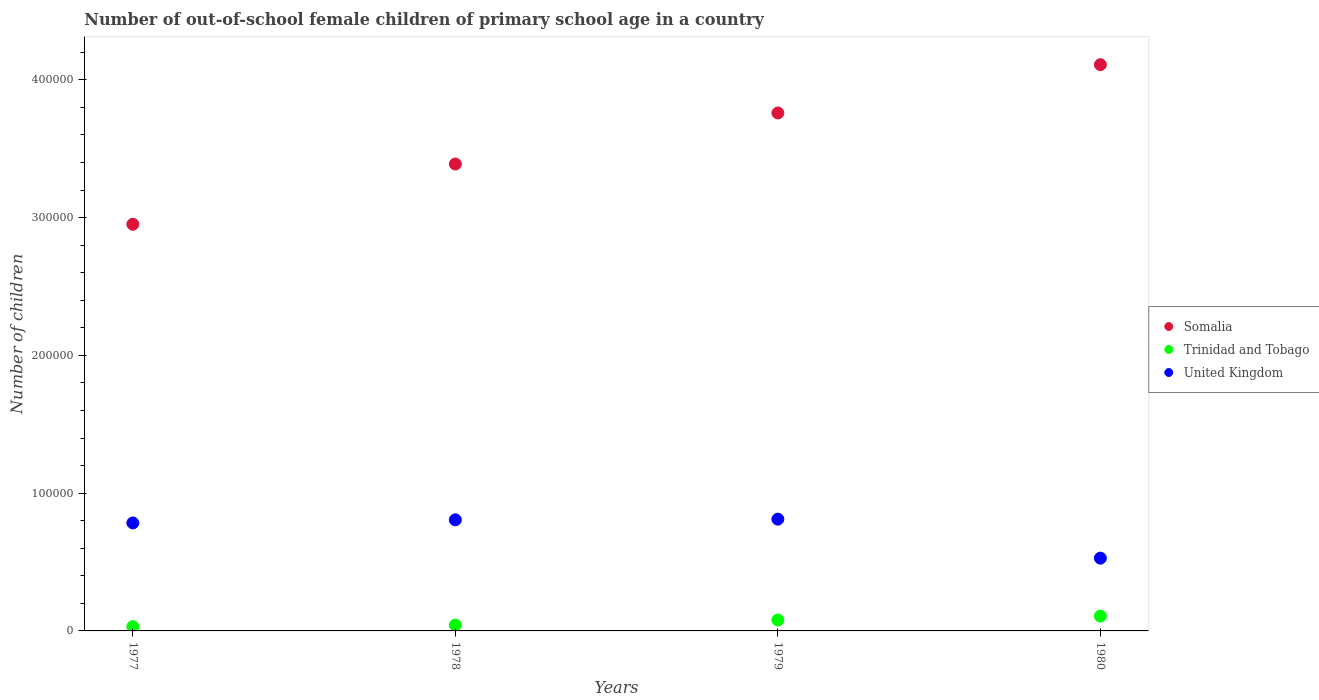How many different coloured dotlines are there?
Your response must be concise. 3. What is the number of out-of-school female children in United Kingdom in 1980?
Ensure brevity in your answer.  5.28e+04. Across all years, what is the maximum number of out-of-school female children in Trinidad and Tobago?
Provide a short and direct response. 1.08e+04. Across all years, what is the minimum number of out-of-school female children in Somalia?
Your answer should be very brief. 2.95e+05. In which year was the number of out-of-school female children in Trinidad and Tobago maximum?
Provide a short and direct response. 1980. What is the total number of out-of-school female children in United Kingdom in the graph?
Ensure brevity in your answer.  2.93e+05. What is the difference between the number of out-of-school female children in Somalia in 1977 and that in 1979?
Give a very brief answer. -8.08e+04. What is the difference between the number of out-of-school female children in Somalia in 1979 and the number of out-of-school female children in United Kingdom in 1980?
Ensure brevity in your answer.  3.23e+05. What is the average number of out-of-school female children in Trinidad and Tobago per year?
Keep it short and to the point. 6522.25. In the year 1978, what is the difference between the number of out-of-school female children in Somalia and number of out-of-school female children in Trinidad and Tobago?
Your response must be concise. 3.35e+05. In how many years, is the number of out-of-school female children in United Kingdom greater than 60000?
Make the answer very short. 3. What is the ratio of the number of out-of-school female children in Somalia in 1978 to that in 1980?
Your response must be concise. 0.82. What is the difference between the highest and the second highest number of out-of-school female children in United Kingdom?
Offer a terse response. 479. What is the difference between the highest and the lowest number of out-of-school female children in Trinidad and Tobago?
Your answer should be compact. 7644. Is it the case that in every year, the sum of the number of out-of-school female children in Somalia and number of out-of-school female children in Trinidad and Tobago  is greater than the number of out-of-school female children in United Kingdom?
Make the answer very short. Yes. Does the number of out-of-school female children in United Kingdom monotonically increase over the years?
Provide a short and direct response. No. Is the number of out-of-school female children in United Kingdom strictly less than the number of out-of-school female children in Somalia over the years?
Ensure brevity in your answer.  Yes. How many dotlines are there?
Your answer should be very brief. 3. Does the graph contain grids?
Your response must be concise. No. What is the title of the graph?
Give a very brief answer. Number of out-of-school female children of primary school age in a country. What is the label or title of the Y-axis?
Give a very brief answer. Number of children. What is the Number of children of Somalia in 1977?
Provide a succinct answer. 2.95e+05. What is the Number of children in Trinidad and Tobago in 1977?
Keep it short and to the point. 3116. What is the Number of children in United Kingdom in 1977?
Provide a short and direct response. 7.84e+04. What is the Number of children in Somalia in 1978?
Your response must be concise. 3.39e+05. What is the Number of children of Trinidad and Tobago in 1978?
Offer a very short reply. 4266. What is the Number of children in United Kingdom in 1978?
Provide a short and direct response. 8.06e+04. What is the Number of children in Somalia in 1979?
Ensure brevity in your answer.  3.76e+05. What is the Number of children in Trinidad and Tobago in 1979?
Ensure brevity in your answer.  7947. What is the Number of children of United Kingdom in 1979?
Offer a terse response. 8.11e+04. What is the Number of children of Somalia in 1980?
Make the answer very short. 4.11e+05. What is the Number of children in Trinidad and Tobago in 1980?
Your answer should be compact. 1.08e+04. What is the Number of children in United Kingdom in 1980?
Your answer should be compact. 5.28e+04. Across all years, what is the maximum Number of children in Somalia?
Provide a short and direct response. 4.11e+05. Across all years, what is the maximum Number of children of Trinidad and Tobago?
Offer a very short reply. 1.08e+04. Across all years, what is the maximum Number of children of United Kingdom?
Offer a very short reply. 8.11e+04. Across all years, what is the minimum Number of children in Somalia?
Provide a succinct answer. 2.95e+05. Across all years, what is the minimum Number of children in Trinidad and Tobago?
Keep it short and to the point. 3116. Across all years, what is the minimum Number of children in United Kingdom?
Offer a terse response. 5.28e+04. What is the total Number of children in Somalia in the graph?
Your response must be concise. 1.42e+06. What is the total Number of children in Trinidad and Tobago in the graph?
Provide a short and direct response. 2.61e+04. What is the total Number of children of United Kingdom in the graph?
Ensure brevity in your answer.  2.93e+05. What is the difference between the Number of children of Somalia in 1977 and that in 1978?
Your answer should be very brief. -4.37e+04. What is the difference between the Number of children of Trinidad and Tobago in 1977 and that in 1978?
Your response must be concise. -1150. What is the difference between the Number of children of United Kingdom in 1977 and that in 1978?
Your answer should be very brief. -2261. What is the difference between the Number of children in Somalia in 1977 and that in 1979?
Offer a very short reply. -8.08e+04. What is the difference between the Number of children of Trinidad and Tobago in 1977 and that in 1979?
Offer a very short reply. -4831. What is the difference between the Number of children of United Kingdom in 1977 and that in 1979?
Your response must be concise. -2740. What is the difference between the Number of children of Somalia in 1977 and that in 1980?
Your response must be concise. -1.16e+05. What is the difference between the Number of children in Trinidad and Tobago in 1977 and that in 1980?
Offer a terse response. -7644. What is the difference between the Number of children in United Kingdom in 1977 and that in 1980?
Give a very brief answer. 2.56e+04. What is the difference between the Number of children of Somalia in 1978 and that in 1979?
Ensure brevity in your answer.  -3.71e+04. What is the difference between the Number of children in Trinidad and Tobago in 1978 and that in 1979?
Keep it short and to the point. -3681. What is the difference between the Number of children of United Kingdom in 1978 and that in 1979?
Your answer should be very brief. -479. What is the difference between the Number of children of Somalia in 1978 and that in 1980?
Keep it short and to the point. -7.21e+04. What is the difference between the Number of children in Trinidad and Tobago in 1978 and that in 1980?
Give a very brief answer. -6494. What is the difference between the Number of children in United Kingdom in 1978 and that in 1980?
Your answer should be compact. 2.78e+04. What is the difference between the Number of children in Somalia in 1979 and that in 1980?
Your answer should be compact. -3.51e+04. What is the difference between the Number of children in Trinidad and Tobago in 1979 and that in 1980?
Provide a short and direct response. -2813. What is the difference between the Number of children in United Kingdom in 1979 and that in 1980?
Offer a very short reply. 2.83e+04. What is the difference between the Number of children in Somalia in 1977 and the Number of children in Trinidad and Tobago in 1978?
Your answer should be compact. 2.91e+05. What is the difference between the Number of children in Somalia in 1977 and the Number of children in United Kingdom in 1978?
Keep it short and to the point. 2.15e+05. What is the difference between the Number of children in Trinidad and Tobago in 1977 and the Number of children in United Kingdom in 1978?
Make the answer very short. -7.75e+04. What is the difference between the Number of children in Somalia in 1977 and the Number of children in Trinidad and Tobago in 1979?
Provide a succinct answer. 2.87e+05. What is the difference between the Number of children in Somalia in 1977 and the Number of children in United Kingdom in 1979?
Ensure brevity in your answer.  2.14e+05. What is the difference between the Number of children of Trinidad and Tobago in 1977 and the Number of children of United Kingdom in 1979?
Ensure brevity in your answer.  -7.80e+04. What is the difference between the Number of children of Somalia in 1977 and the Number of children of Trinidad and Tobago in 1980?
Provide a short and direct response. 2.84e+05. What is the difference between the Number of children of Somalia in 1977 and the Number of children of United Kingdom in 1980?
Offer a very short reply. 2.42e+05. What is the difference between the Number of children of Trinidad and Tobago in 1977 and the Number of children of United Kingdom in 1980?
Provide a succinct answer. -4.97e+04. What is the difference between the Number of children in Somalia in 1978 and the Number of children in Trinidad and Tobago in 1979?
Offer a terse response. 3.31e+05. What is the difference between the Number of children in Somalia in 1978 and the Number of children in United Kingdom in 1979?
Make the answer very short. 2.58e+05. What is the difference between the Number of children in Trinidad and Tobago in 1978 and the Number of children in United Kingdom in 1979?
Make the answer very short. -7.69e+04. What is the difference between the Number of children of Somalia in 1978 and the Number of children of Trinidad and Tobago in 1980?
Offer a very short reply. 3.28e+05. What is the difference between the Number of children of Somalia in 1978 and the Number of children of United Kingdom in 1980?
Your response must be concise. 2.86e+05. What is the difference between the Number of children of Trinidad and Tobago in 1978 and the Number of children of United Kingdom in 1980?
Give a very brief answer. -4.85e+04. What is the difference between the Number of children in Somalia in 1979 and the Number of children in Trinidad and Tobago in 1980?
Give a very brief answer. 3.65e+05. What is the difference between the Number of children of Somalia in 1979 and the Number of children of United Kingdom in 1980?
Your response must be concise. 3.23e+05. What is the difference between the Number of children of Trinidad and Tobago in 1979 and the Number of children of United Kingdom in 1980?
Provide a short and direct response. -4.49e+04. What is the average Number of children in Somalia per year?
Make the answer very short. 3.55e+05. What is the average Number of children in Trinidad and Tobago per year?
Offer a very short reply. 6522.25. What is the average Number of children in United Kingdom per year?
Provide a succinct answer. 7.32e+04. In the year 1977, what is the difference between the Number of children in Somalia and Number of children in Trinidad and Tobago?
Your response must be concise. 2.92e+05. In the year 1977, what is the difference between the Number of children of Somalia and Number of children of United Kingdom?
Your answer should be compact. 2.17e+05. In the year 1977, what is the difference between the Number of children of Trinidad and Tobago and Number of children of United Kingdom?
Make the answer very short. -7.53e+04. In the year 1978, what is the difference between the Number of children in Somalia and Number of children in Trinidad and Tobago?
Offer a very short reply. 3.35e+05. In the year 1978, what is the difference between the Number of children in Somalia and Number of children in United Kingdom?
Your response must be concise. 2.58e+05. In the year 1978, what is the difference between the Number of children of Trinidad and Tobago and Number of children of United Kingdom?
Your response must be concise. -7.64e+04. In the year 1979, what is the difference between the Number of children of Somalia and Number of children of Trinidad and Tobago?
Your answer should be compact. 3.68e+05. In the year 1979, what is the difference between the Number of children of Somalia and Number of children of United Kingdom?
Make the answer very short. 2.95e+05. In the year 1979, what is the difference between the Number of children of Trinidad and Tobago and Number of children of United Kingdom?
Your response must be concise. -7.32e+04. In the year 1980, what is the difference between the Number of children of Somalia and Number of children of Trinidad and Tobago?
Your response must be concise. 4.00e+05. In the year 1980, what is the difference between the Number of children of Somalia and Number of children of United Kingdom?
Provide a succinct answer. 3.58e+05. In the year 1980, what is the difference between the Number of children of Trinidad and Tobago and Number of children of United Kingdom?
Your answer should be very brief. -4.21e+04. What is the ratio of the Number of children in Somalia in 1977 to that in 1978?
Provide a short and direct response. 0.87. What is the ratio of the Number of children in Trinidad and Tobago in 1977 to that in 1978?
Offer a terse response. 0.73. What is the ratio of the Number of children of Somalia in 1977 to that in 1979?
Keep it short and to the point. 0.79. What is the ratio of the Number of children of Trinidad and Tobago in 1977 to that in 1979?
Your response must be concise. 0.39. What is the ratio of the Number of children of United Kingdom in 1977 to that in 1979?
Offer a terse response. 0.97. What is the ratio of the Number of children of Somalia in 1977 to that in 1980?
Offer a terse response. 0.72. What is the ratio of the Number of children in Trinidad and Tobago in 1977 to that in 1980?
Keep it short and to the point. 0.29. What is the ratio of the Number of children of United Kingdom in 1977 to that in 1980?
Give a very brief answer. 1.48. What is the ratio of the Number of children of Somalia in 1978 to that in 1979?
Give a very brief answer. 0.9. What is the ratio of the Number of children in Trinidad and Tobago in 1978 to that in 1979?
Keep it short and to the point. 0.54. What is the ratio of the Number of children in Somalia in 1978 to that in 1980?
Provide a succinct answer. 0.82. What is the ratio of the Number of children of Trinidad and Tobago in 1978 to that in 1980?
Ensure brevity in your answer.  0.4. What is the ratio of the Number of children in United Kingdom in 1978 to that in 1980?
Keep it short and to the point. 1.53. What is the ratio of the Number of children of Somalia in 1979 to that in 1980?
Give a very brief answer. 0.91. What is the ratio of the Number of children of Trinidad and Tobago in 1979 to that in 1980?
Your answer should be compact. 0.74. What is the ratio of the Number of children in United Kingdom in 1979 to that in 1980?
Make the answer very short. 1.54. What is the difference between the highest and the second highest Number of children of Somalia?
Keep it short and to the point. 3.51e+04. What is the difference between the highest and the second highest Number of children in Trinidad and Tobago?
Keep it short and to the point. 2813. What is the difference between the highest and the second highest Number of children of United Kingdom?
Ensure brevity in your answer.  479. What is the difference between the highest and the lowest Number of children in Somalia?
Offer a terse response. 1.16e+05. What is the difference between the highest and the lowest Number of children of Trinidad and Tobago?
Offer a terse response. 7644. What is the difference between the highest and the lowest Number of children in United Kingdom?
Give a very brief answer. 2.83e+04. 